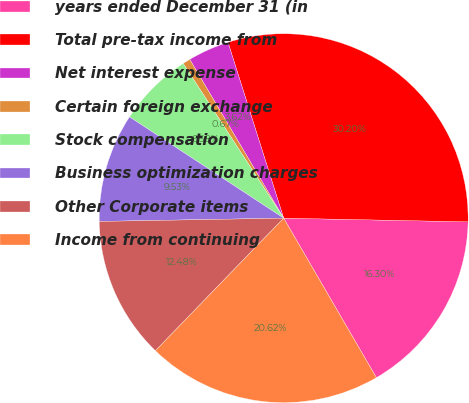Convert chart to OTSL. <chart><loc_0><loc_0><loc_500><loc_500><pie_chart><fcel>years ended December 31 (in<fcel>Total pre-tax income from<fcel>Net interest expense<fcel>Certain foreign exchange<fcel>Stock compensation<fcel>Business optimization charges<fcel>Other Corporate items<fcel>Income from continuing<nl><fcel>16.3%<fcel>30.2%<fcel>3.62%<fcel>0.67%<fcel>6.58%<fcel>9.53%<fcel>12.48%<fcel>20.62%<nl></chart> 